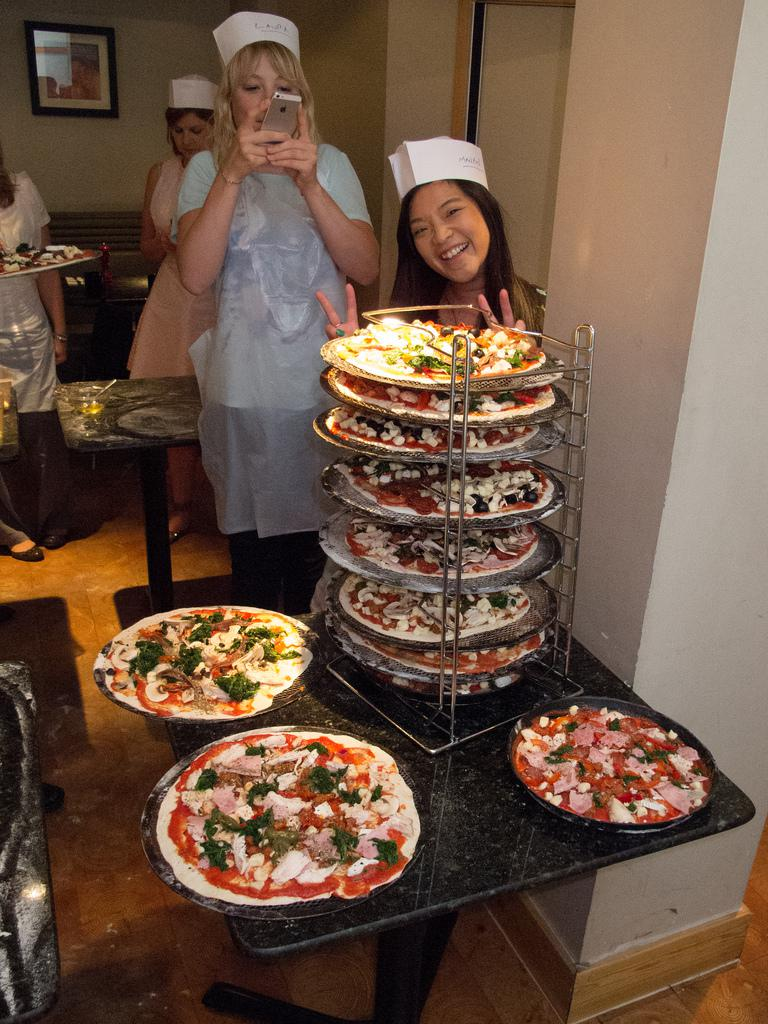Question: what are these people doing?
Choices:
A. Eating lunch.
B. Having drinks.
C. Watching a movie.
D. Stacking pizzas.
Answer with the letter. Answer: D Question: how many pizzas are there?
Choices:
A. Eleven.
B. Four.
C. Five.
D. Six.
Answer with the letter. Answer: A Question: what is the girl holding in her hand?
Choices:
A. A flower.
B. A book.
C. A doll.
D. Cell phone.
Answer with the letter. Answer: D Question: when will the girls get to eat the pizza?
Choices:
A. After the over timer goes off.
B. After baking.
C. After it is delivered.
D. After it cools off.
Answer with the letter. Answer: B Question: what are the pizzas sitting on?
Choices:
A. A counter.
B. A bench.
C. A chair.
D. A table.
Answer with the letter. Answer: D Question: why is the girl smiling?
Choices:
A. Made the pizzas.
B. She likes pizza.
C. She is happy.
D. She will have ice cream for dessert.
Answer with the letter. Answer: A Question: where is the woman standing?
Choices:
A. In front of the sign.
B. Next to the boy.
C. Behind pizza.
D. At the kitchen counter.
Answer with the letter. Answer: C Question: what is on the back wall?
Choices:
A. Christmas Stockings.
B. A deer head.
C. A picture.
D. A dart board.
Answer with the letter. Answer: C Question: how many women are wearing white caps?
Choices:
A. Two.
B. None.
C. Four.
D. Three.
Answer with the letter. Answer: D Question: what do the pizzas sit on?
Choices:
A. A pizza box.
B. A glass serving plate.
C. A tray.
D. A metal tier.
Answer with the letter. Answer: D Question: what color are the walls?
Choices:
A. Gray.
B. Light green.
C. Off-white.
D. Lavender.
Answer with the letter. Answer: C Question: what is ready to go in the oven?
Choices:
A. A cake.
B. An apple pie.
C. Pizzas.
D. A chicken.
Answer with the letter. Answer: C Question: how many uncooked pizzas on the table?
Choices:
A. Ten.
B. Eleven.
C. Eight.
D. Thirteen.
Answer with the letter. Answer: A Question: who is holding an iphone?
Choices:
A. The man.
B. A child.
C. A teenager.
D. The woman.
Answer with the letter. Answer: D Question: how many pizzas are there total?
Choices:
A. Eleven.
B. Twelve.
C. Thirteen.
D. Ten.
Answer with the letter. Answer: A Question: who stands over the pizzas?
Choices:
A. A male chef.
B. A pizza chef.
C. A sous chef.
D. A female chef.
Answer with the letter. Answer: D Question: what is on the pizzas?
Choices:
A. A few toppings.
B. A lot of toppings.
C. No toppings.
D. Sparse toppings.
Answer with the letter. Answer: B Question: what color is the table?
Choices:
A. Brown.
B. White.
C. Grey.
D. Black.
Answer with the letter. Answer: D Question: where is the metal rack with the pizzas sitting?
Choices:
A. On a counter.
B. On a shelf.
C. On the floor.
D. On a table.
Answer with the letter. Answer: D Question: who is taking a picture of the cook with the pizzas?
Choices:
A. A man.
B. A boy.
C. A girl.
D. Another woman.
Answer with the letter. Answer: D Question: who is posing at the table with her pizzas?
Choices:
A. The child eating a pizza.
B. The woman smiling at her husband.
C. The chef.
D. The man looking at the pizza.
Answer with the letter. Answer: C 